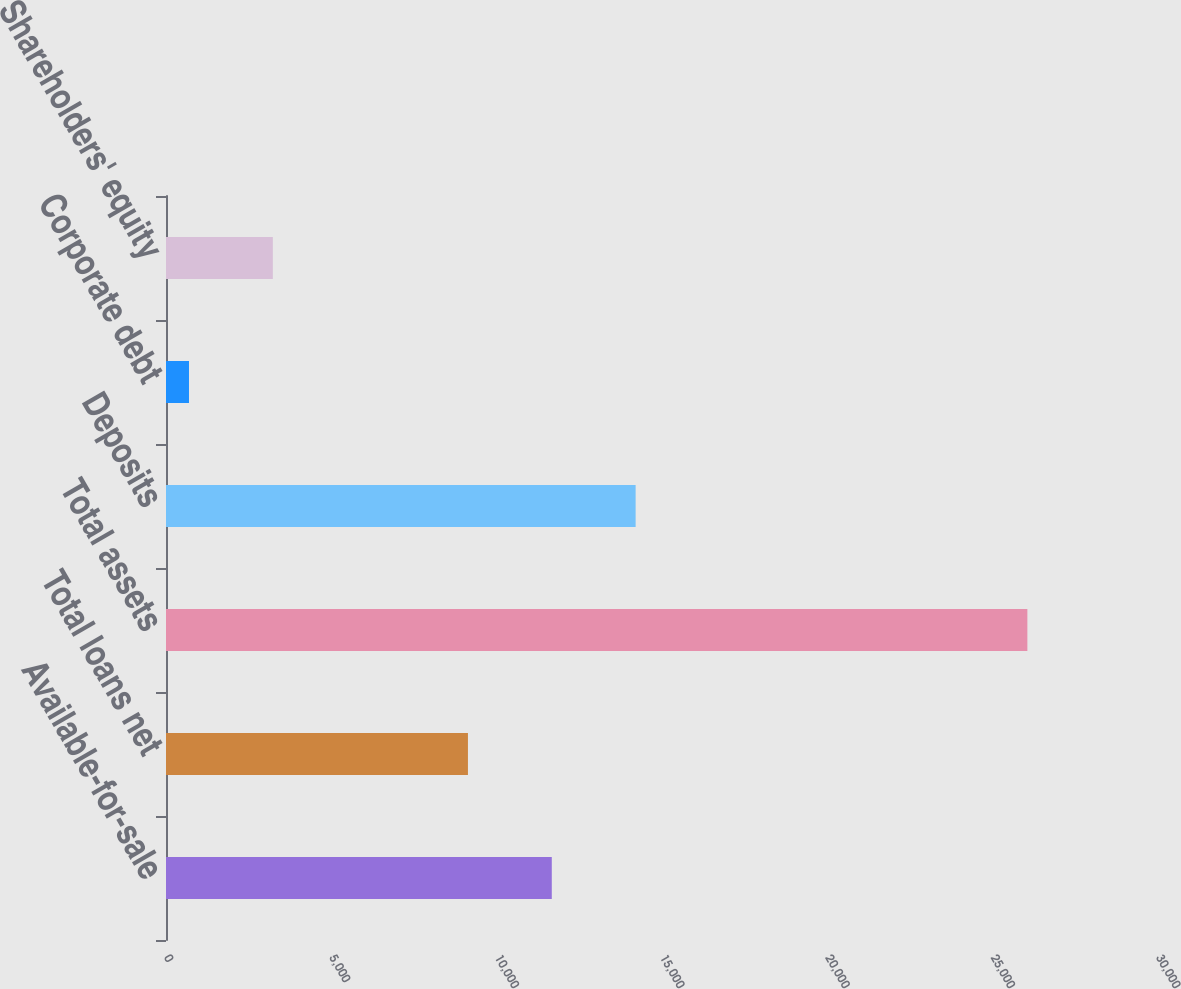Convert chart. <chart><loc_0><loc_0><loc_500><loc_500><bar_chart><fcel>Available-for-sale<fcel>Total loans net<fcel>Total assets<fcel>Deposits<fcel>Corporate debt<fcel>Shareholders' equity<nl><fcel>11666.8<fcel>9131.4<fcel>26049.2<fcel>14202.2<fcel>695.3<fcel>3230.69<nl></chart> 